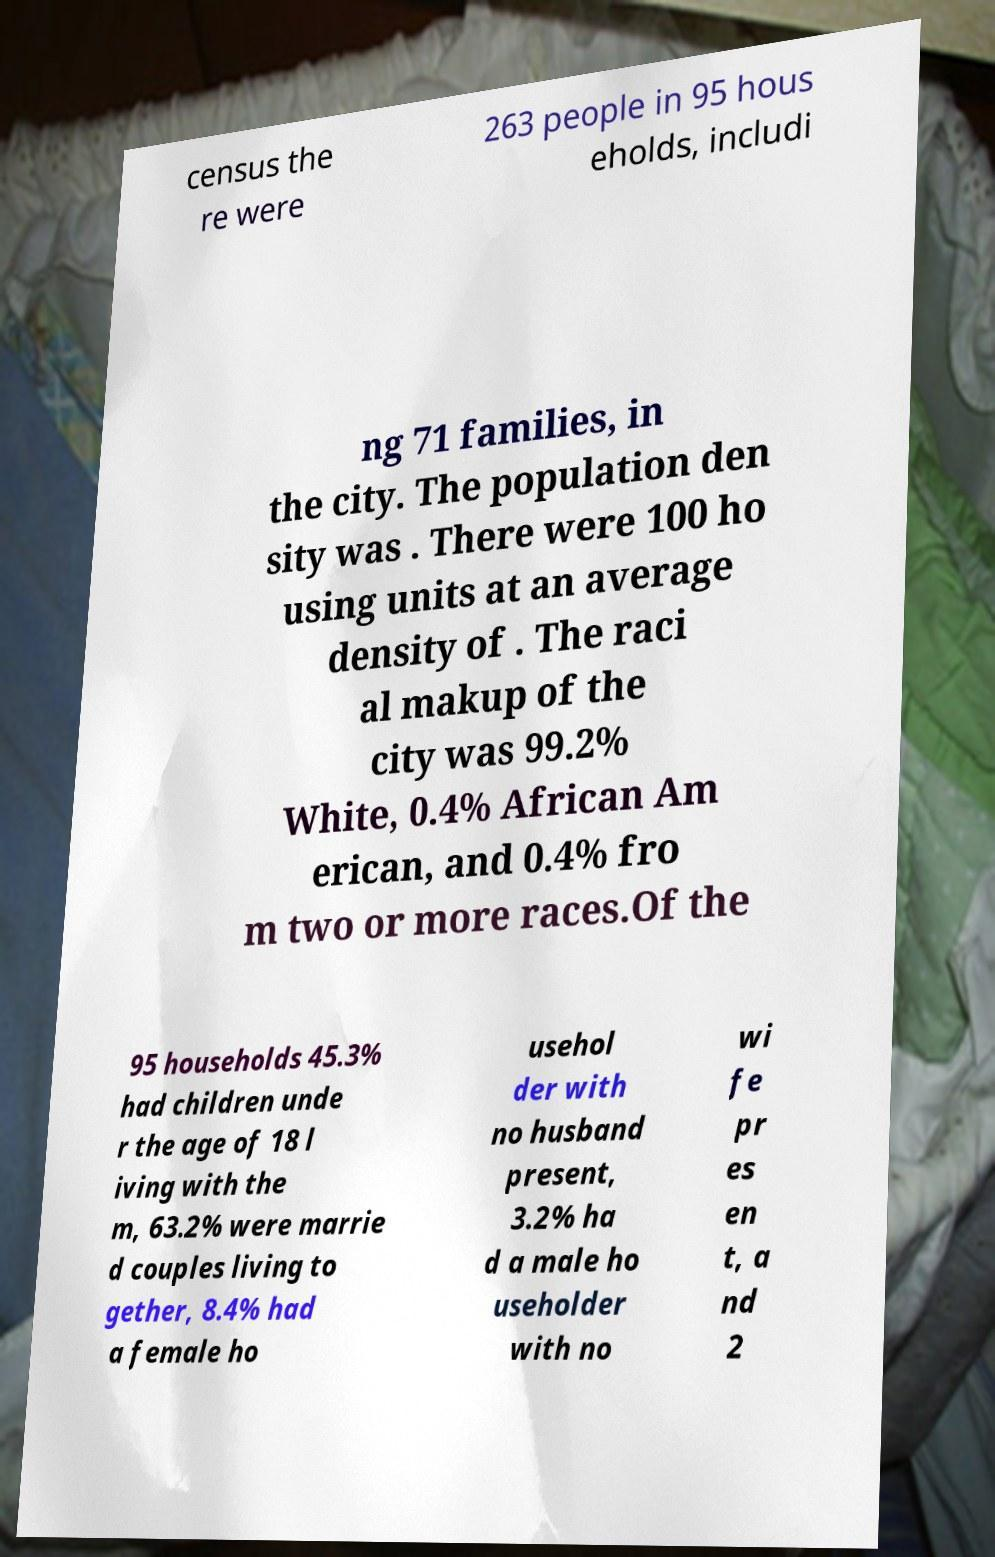Can you read and provide the text displayed in the image?This photo seems to have some interesting text. Can you extract and type it out for me? census the re were 263 people in 95 hous eholds, includi ng 71 families, in the city. The population den sity was . There were 100 ho using units at an average density of . The raci al makup of the city was 99.2% White, 0.4% African Am erican, and 0.4% fro m two or more races.Of the 95 households 45.3% had children unde r the age of 18 l iving with the m, 63.2% were marrie d couples living to gether, 8.4% had a female ho usehol der with no husband present, 3.2% ha d a male ho useholder with no wi fe pr es en t, a nd 2 